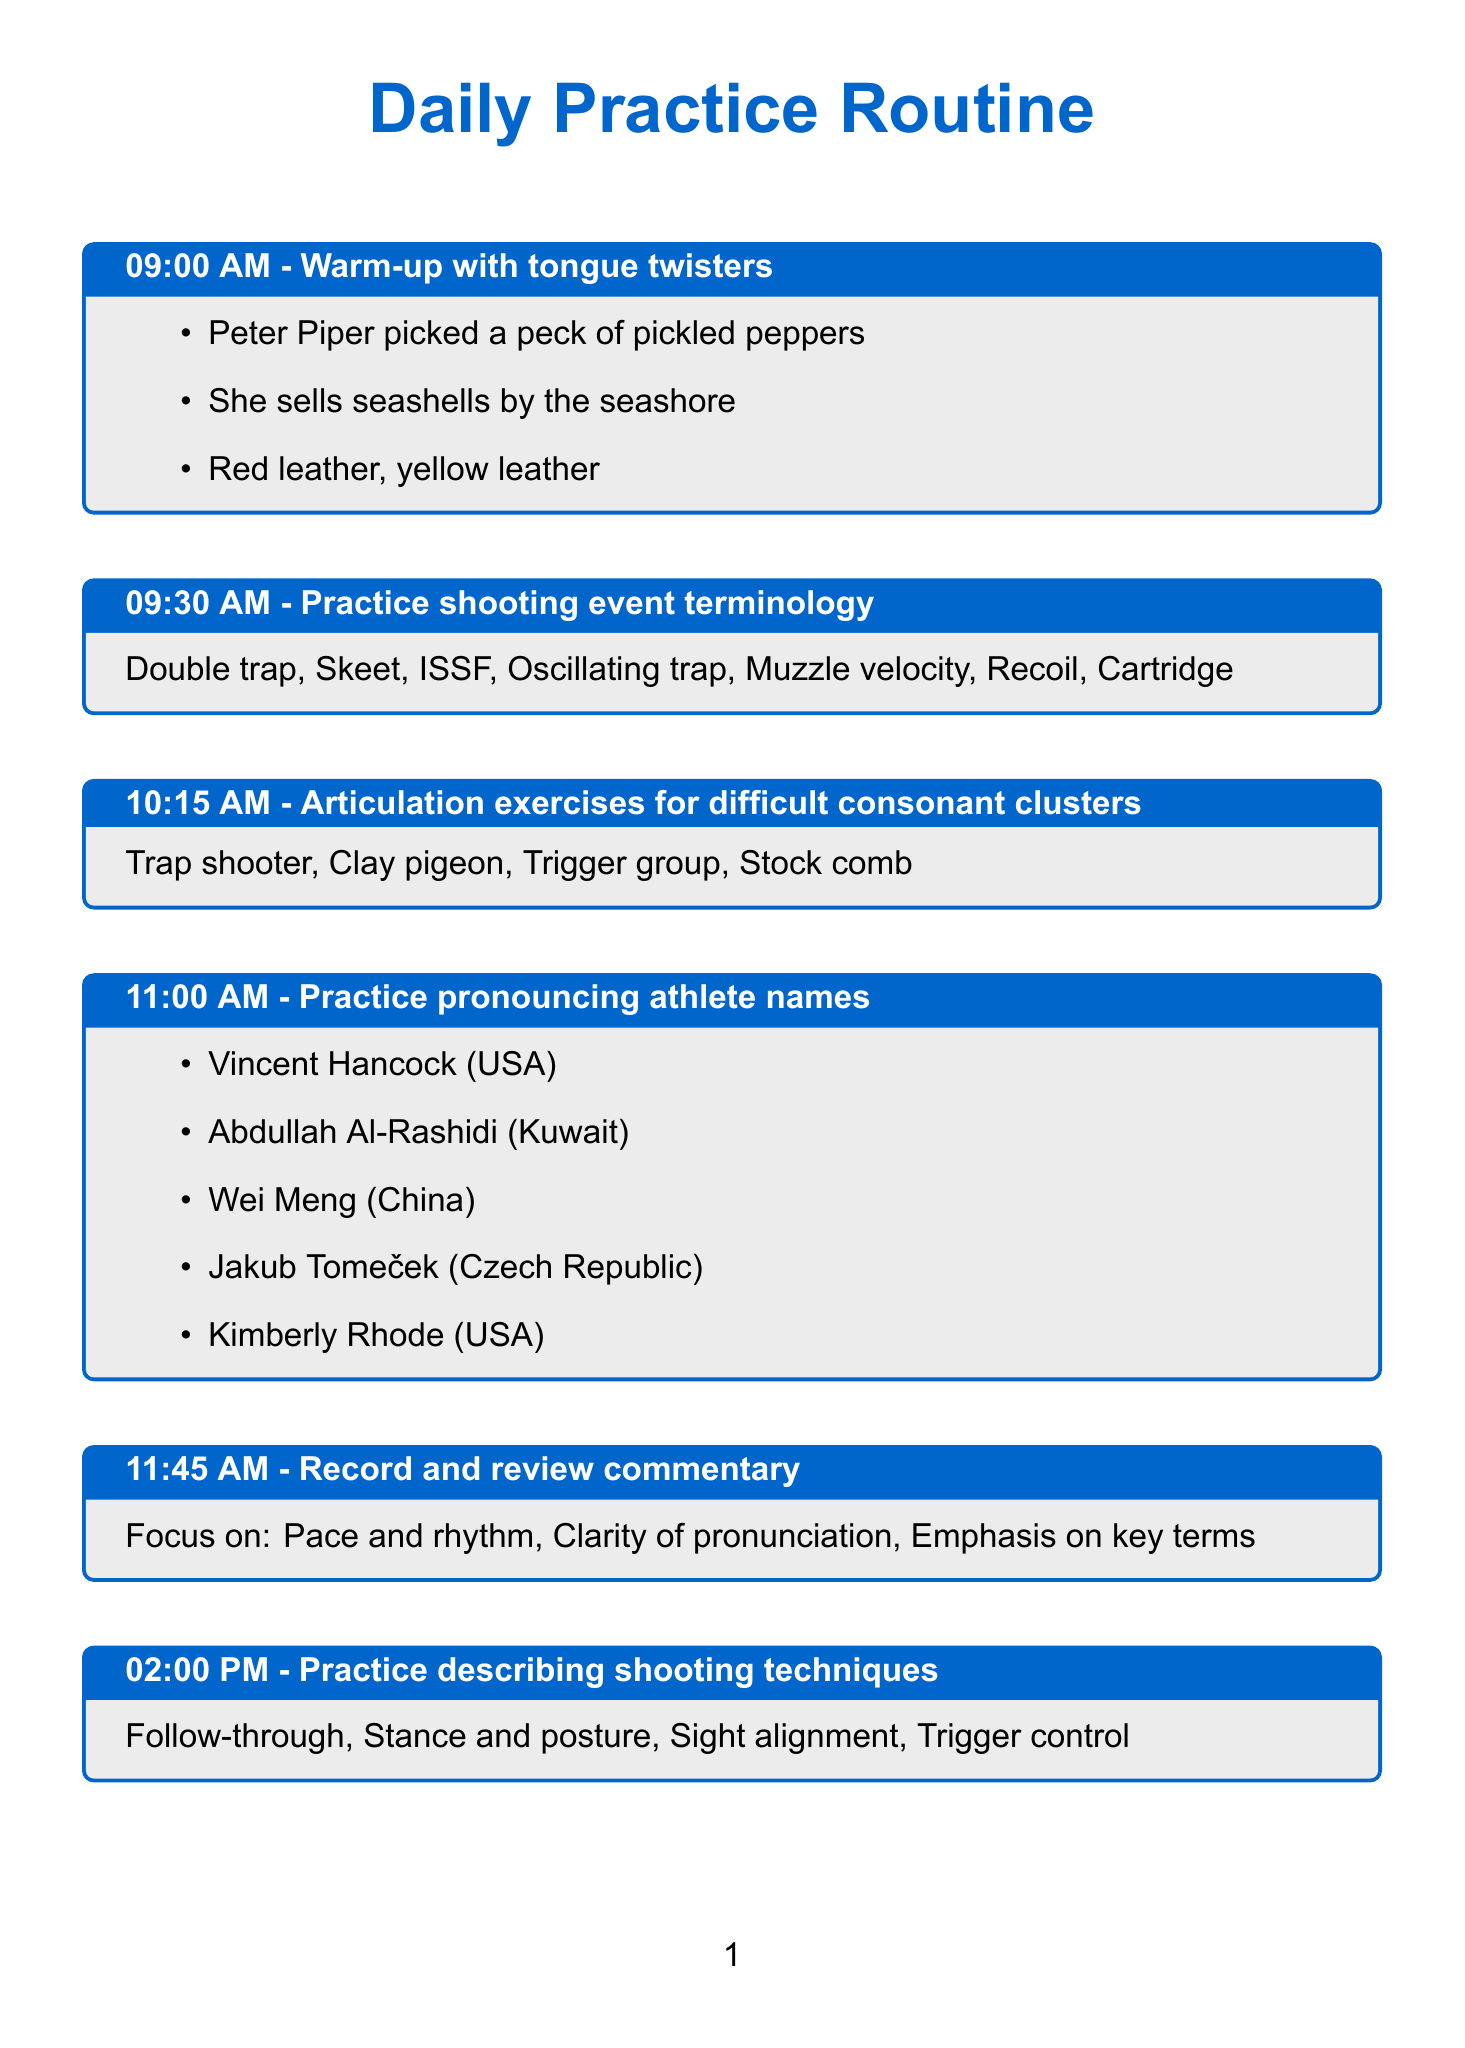What time is the warm-up scheduled? The warm-up activity is scheduled at 09:00 AM.
Answer: 09:00 AM What activity is planned at 11:00 AM? The activity planned at 11:00 AM is to practice pronouncing athlete names.
Answer: Practice pronouncing athlete names Which athlete represents Kuwait? The athlete representing Kuwait is Abdullah Al-Rashidi.
Answer: Abdullah Al-Rashidi What are the focus areas during the recording and review commentary session? The focus areas are pace and rhythm, clarity of pronunciation, and emphasis on key terms.
Answer: Pace and rhythm, Clarity of pronunciation, Emphasis on key terms How many shooting venues are listed in the schedule? The schedule lists four shooting venues.
Answer: Four What is the last activity of the day? The last activity of the day is reviewing and practicing new shooting rules and regulations.
Answer: Review and practice new shooting rules and regulations What technique is NOT mentioned in the practice session? The technique not mentioned is trigger control.
Answer: Trigger control What time is the rapid-fire commentary practice? The rapid-fire commentary practice is at 04:00 PM.
Answer: 04:00 PM 